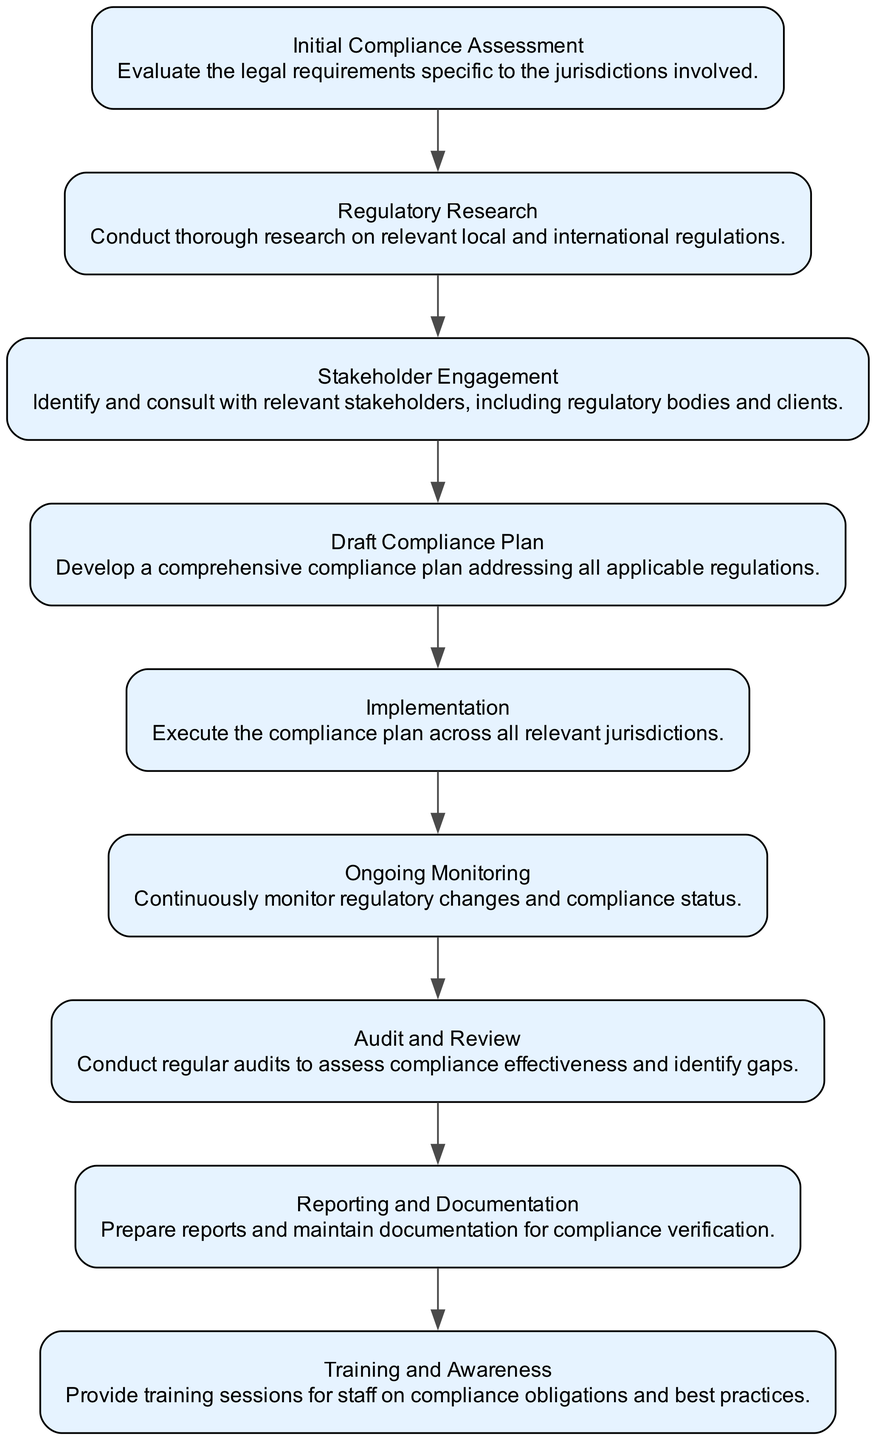What is the first step in the workflow? The first node in the flowchart is "Initial Compliance Assessment." It is the starting point of the compliance workflow outlined in the diagram.
Answer: Initial Compliance Assessment How many nodes are there in total? The diagram contains 9 nodes, each representing a specific step in the compliance workflow.
Answer: 9 What node immediately follows "Regulatory Research"? "Stakeholder Engagement" directly comes after "Regulatory Research" as per the flow of the diagram.
Answer: Stakeholder Engagement Which step involves providing training sessions? The "Training and Awareness" node is the step that includes providing training sessions for staff regarding compliance obligations.
Answer: Training and Awareness What is the last step of the compliance workflow? The final node in the flow is "Reporting and Documentation," indicating that this is the concluding activity of the compliance process.
Answer: Reporting and Documentation What is the connection between "Implementation" and "Ongoing Monitoring"? "Ongoing Monitoring" follows "Implementation" in the workflow, indicating that after implementing the compliance plan, there is a need for continuous monitoring of regulatory changes and compliance status.
Answer: Ongoing Monitoring How does "Audit and Review" relate to "Ongoing Monitoring"? "Audit and Review" comes after "Ongoing Monitoring" in the diagram, suggesting that regular audits occur following ongoing checks to assess compliance effectiveness and identify any gaps.
Answer: Audit and Review What is the purpose of the "Draft Compliance Plan"? The purpose of the "Draft Compliance Plan" is to develop a comprehensive strategy that addresses all applicable regulations after researching and discussing with stakeholders.
Answer: Develop a comprehensive compliance plan What is the function of the "Stakeholder Engagement" step? The "Stakeholder Engagement" step functions to identify and consult with relevant stakeholders, including regulatory bodies and clients, to ensure all perspectives are considered in the compliance process.
Answer: Identify and consult with relevant stakeholders 